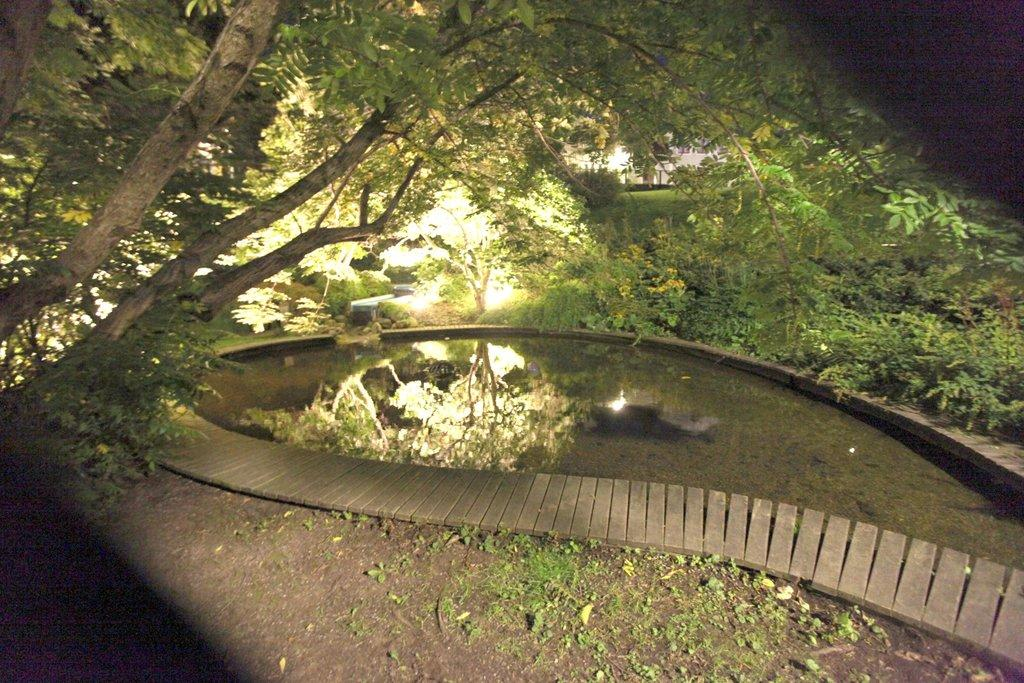What is the main feature in the middle of the image? There is a pond at the center of the image. What can be seen in the background of the image? There are trees in the background of the image. What type of stamp can be seen on the pond in the image? There is no stamp present on the pond in the image. What flavor of cracker is floating in the pond? There are no crackers present in the image, let alone floating in the pond. 